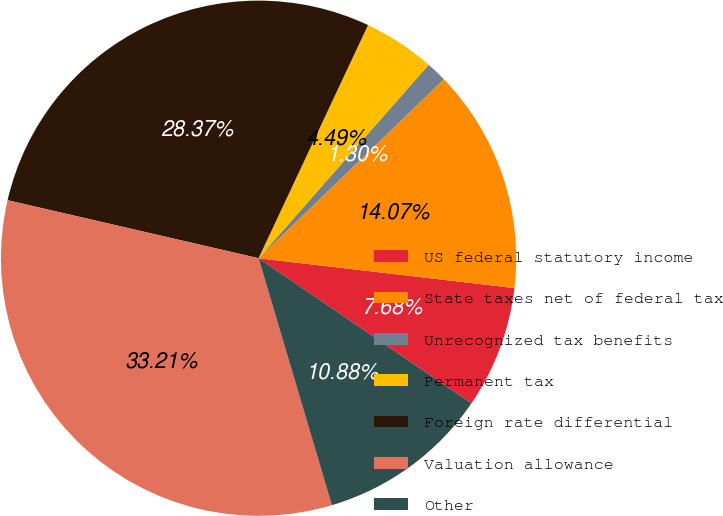Convert chart to OTSL. <chart><loc_0><loc_0><loc_500><loc_500><pie_chart><fcel>US federal statutory income<fcel>State taxes net of federal tax<fcel>Unrecognized tax benefits<fcel>Permanent tax<fcel>Foreign rate differential<fcel>Valuation allowance<fcel>Other<nl><fcel>7.68%<fcel>14.07%<fcel>1.3%<fcel>4.49%<fcel>28.37%<fcel>33.21%<fcel>10.88%<nl></chart> 